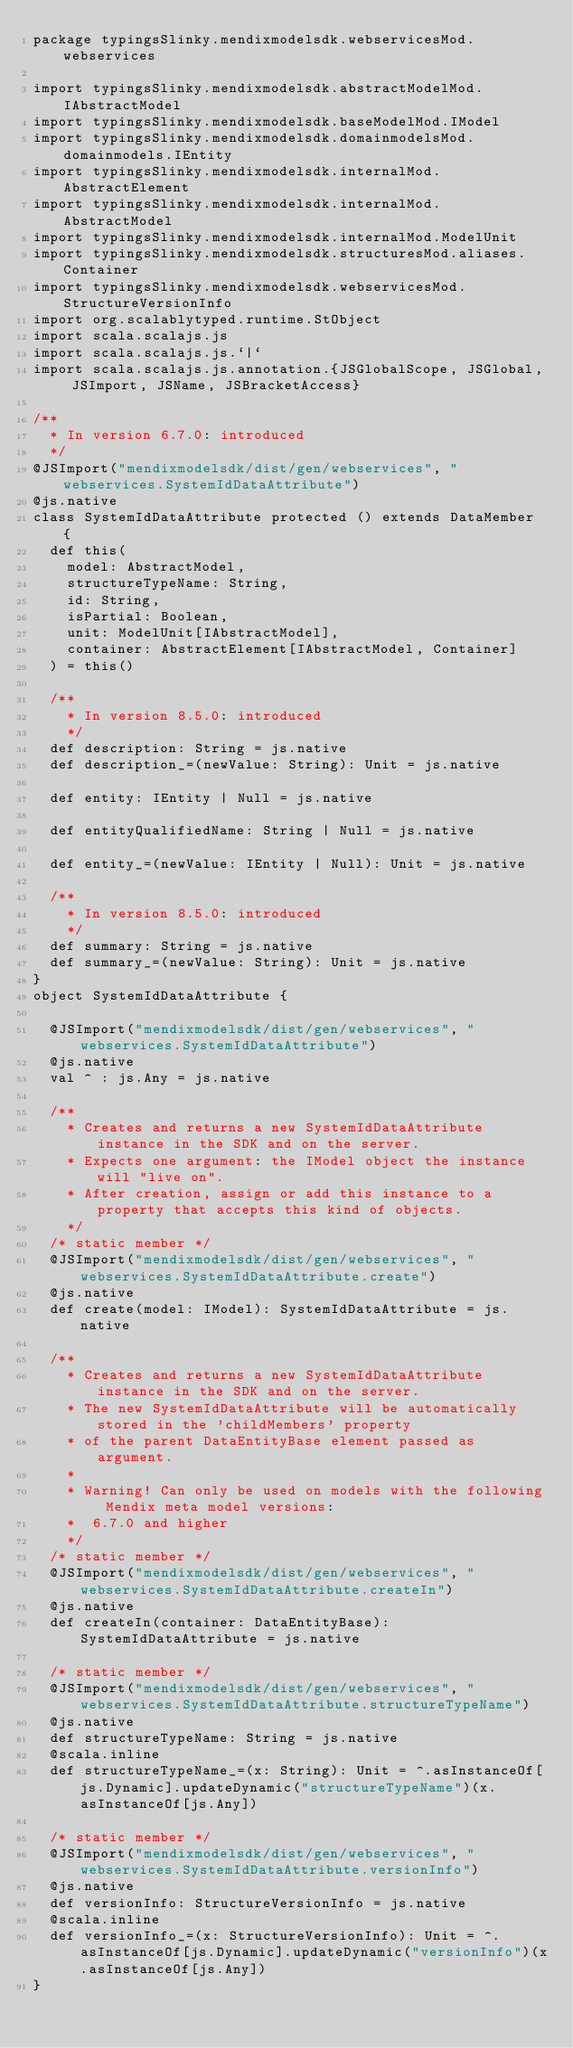<code> <loc_0><loc_0><loc_500><loc_500><_Scala_>package typingsSlinky.mendixmodelsdk.webservicesMod.webservices

import typingsSlinky.mendixmodelsdk.abstractModelMod.IAbstractModel
import typingsSlinky.mendixmodelsdk.baseModelMod.IModel
import typingsSlinky.mendixmodelsdk.domainmodelsMod.domainmodels.IEntity
import typingsSlinky.mendixmodelsdk.internalMod.AbstractElement
import typingsSlinky.mendixmodelsdk.internalMod.AbstractModel
import typingsSlinky.mendixmodelsdk.internalMod.ModelUnit
import typingsSlinky.mendixmodelsdk.structuresMod.aliases.Container
import typingsSlinky.mendixmodelsdk.webservicesMod.StructureVersionInfo
import org.scalablytyped.runtime.StObject
import scala.scalajs.js
import scala.scalajs.js.`|`
import scala.scalajs.js.annotation.{JSGlobalScope, JSGlobal, JSImport, JSName, JSBracketAccess}

/**
  * In version 6.7.0: introduced
  */
@JSImport("mendixmodelsdk/dist/gen/webservices", "webservices.SystemIdDataAttribute")
@js.native
class SystemIdDataAttribute protected () extends DataMember {
  def this(
    model: AbstractModel,
    structureTypeName: String,
    id: String,
    isPartial: Boolean,
    unit: ModelUnit[IAbstractModel],
    container: AbstractElement[IAbstractModel, Container]
  ) = this()
  
  /**
    * In version 8.5.0: introduced
    */
  def description: String = js.native
  def description_=(newValue: String): Unit = js.native
  
  def entity: IEntity | Null = js.native
  
  def entityQualifiedName: String | Null = js.native
  
  def entity_=(newValue: IEntity | Null): Unit = js.native
  
  /**
    * In version 8.5.0: introduced
    */
  def summary: String = js.native
  def summary_=(newValue: String): Unit = js.native
}
object SystemIdDataAttribute {
  
  @JSImport("mendixmodelsdk/dist/gen/webservices", "webservices.SystemIdDataAttribute")
  @js.native
  val ^ : js.Any = js.native
  
  /**
    * Creates and returns a new SystemIdDataAttribute instance in the SDK and on the server.
    * Expects one argument: the IModel object the instance will "live on".
    * After creation, assign or add this instance to a property that accepts this kind of objects.
    */
  /* static member */
  @JSImport("mendixmodelsdk/dist/gen/webservices", "webservices.SystemIdDataAttribute.create")
  @js.native
  def create(model: IModel): SystemIdDataAttribute = js.native
  
  /**
    * Creates and returns a new SystemIdDataAttribute instance in the SDK and on the server.
    * The new SystemIdDataAttribute will be automatically stored in the 'childMembers' property
    * of the parent DataEntityBase element passed as argument.
    *
    * Warning! Can only be used on models with the following Mendix meta model versions:
    *  6.7.0 and higher
    */
  /* static member */
  @JSImport("mendixmodelsdk/dist/gen/webservices", "webservices.SystemIdDataAttribute.createIn")
  @js.native
  def createIn(container: DataEntityBase): SystemIdDataAttribute = js.native
  
  /* static member */
  @JSImport("mendixmodelsdk/dist/gen/webservices", "webservices.SystemIdDataAttribute.structureTypeName")
  @js.native
  def structureTypeName: String = js.native
  @scala.inline
  def structureTypeName_=(x: String): Unit = ^.asInstanceOf[js.Dynamic].updateDynamic("structureTypeName")(x.asInstanceOf[js.Any])
  
  /* static member */
  @JSImport("mendixmodelsdk/dist/gen/webservices", "webservices.SystemIdDataAttribute.versionInfo")
  @js.native
  def versionInfo: StructureVersionInfo = js.native
  @scala.inline
  def versionInfo_=(x: StructureVersionInfo): Unit = ^.asInstanceOf[js.Dynamic].updateDynamic("versionInfo")(x.asInstanceOf[js.Any])
}
</code> 